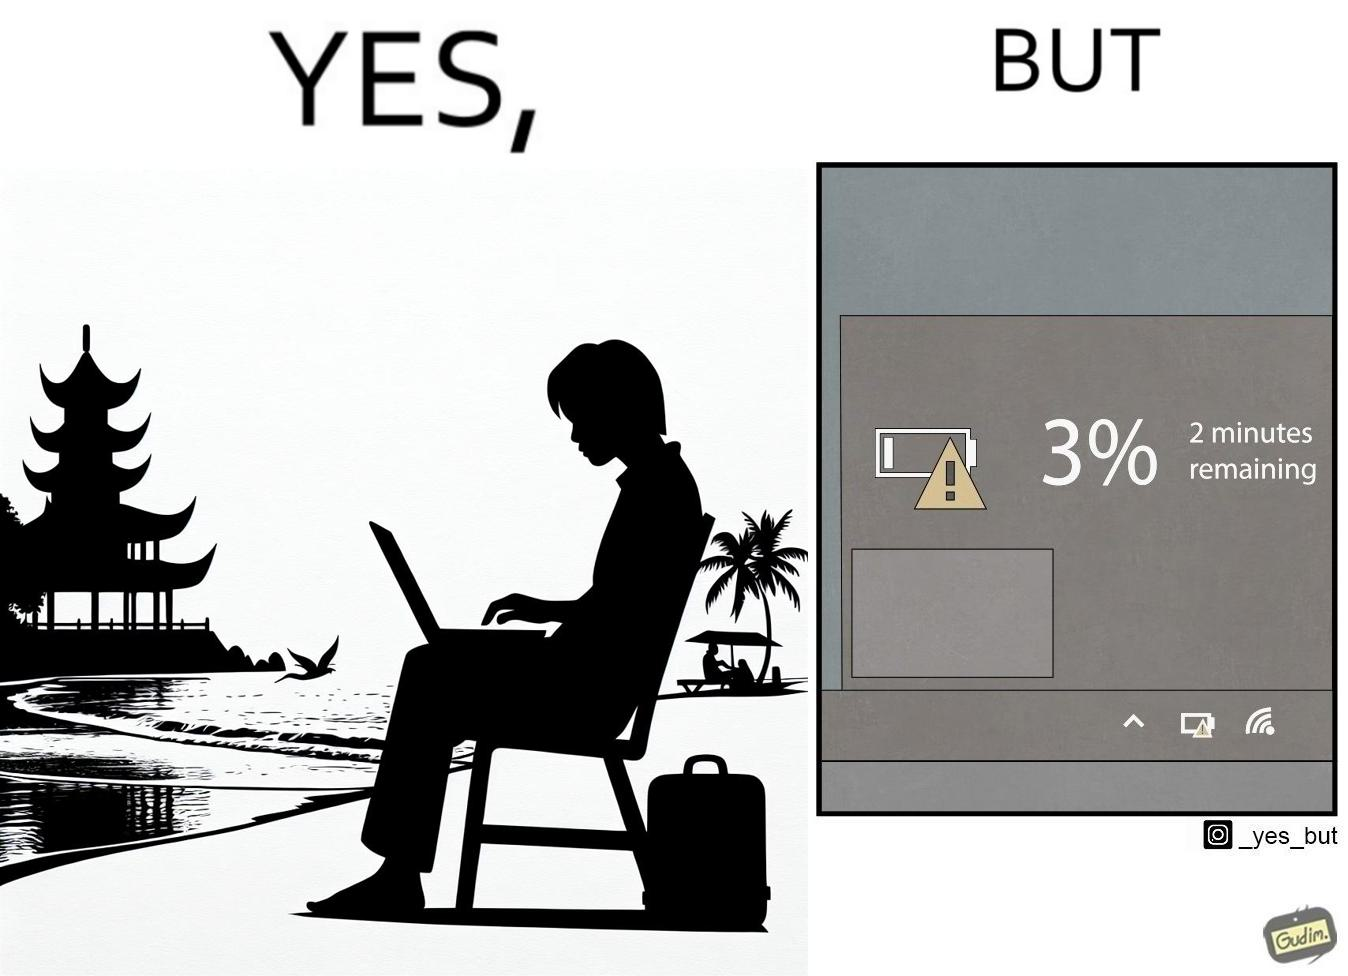Is this a satirical image? Yes, this image is satirical. 